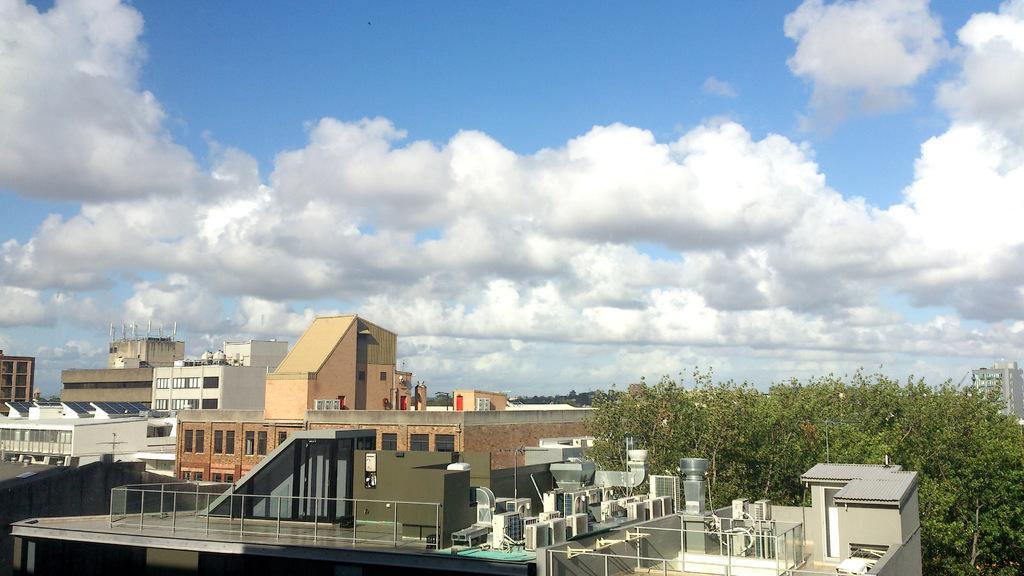Could you give a brief overview of what you see in this image? In this image we can see buildings, air conditioners, trees, solar panels, sky and clouds. 